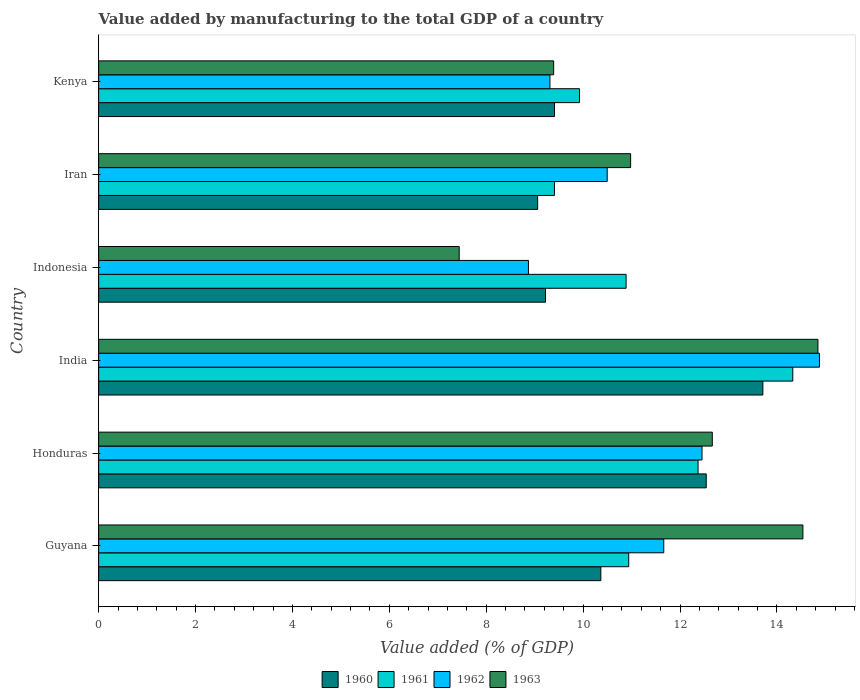How many different coloured bars are there?
Your answer should be very brief. 4. How many groups of bars are there?
Provide a short and direct response. 6. Are the number of bars on each tick of the Y-axis equal?
Your response must be concise. Yes. How many bars are there on the 1st tick from the bottom?
Keep it short and to the point. 4. What is the label of the 6th group of bars from the top?
Your answer should be very brief. Guyana. In how many cases, is the number of bars for a given country not equal to the number of legend labels?
Offer a terse response. 0. What is the value added by manufacturing to the total GDP in 1961 in Honduras?
Your response must be concise. 12.37. Across all countries, what is the maximum value added by manufacturing to the total GDP in 1961?
Your answer should be very brief. 14.33. Across all countries, what is the minimum value added by manufacturing to the total GDP in 1961?
Provide a short and direct response. 9.41. In which country was the value added by manufacturing to the total GDP in 1963 maximum?
Keep it short and to the point. India. What is the total value added by manufacturing to the total GDP in 1960 in the graph?
Make the answer very short. 64.31. What is the difference between the value added by manufacturing to the total GDP in 1960 in India and that in Kenya?
Provide a succinct answer. 4.3. What is the difference between the value added by manufacturing to the total GDP in 1961 in Guyana and the value added by manufacturing to the total GDP in 1960 in Indonesia?
Ensure brevity in your answer.  1.72. What is the average value added by manufacturing to the total GDP in 1963 per country?
Your answer should be very brief. 11.64. What is the difference between the value added by manufacturing to the total GDP in 1962 and value added by manufacturing to the total GDP in 1963 in Kenya?
Your answer should be compact. -0.08. In how many countries, is the value added by manufacturing to the total GDP in 1963 greater than 11.2 %?
Provide a short and direct response. 3. What is the ratio of the value added by manufacturing to the total GDP in 1961 in Guyana to that in Honduras?
Your answer should be compact. 0.88. Is the value added by manufacturing to the total GDP in 1960 in India less than that in Indonesia?
Your answer should be compact. No. Is the difference between the value added by manufacturing to the total GDP in 1962 in Guyana and Indonesia greater than the difference between the value added by manufacturing to the total GDP in 1963 in Guyana and Indonesia?
Offer a terse response. No. What is the difference between the highest and the second highest value added by manufacturing to the total GDP in 1963?
Make the answer very short. 0.31. What is the difference between the highest and the lowest value added by manufacturing to the total GDP in 1962?
Your answer should be compact. 6.01. In how many countries, is the value added by manufacturing to the total GDP in 1961 greater than the average value added by manufacturing to the total GDP in 1961 taken over all countries?
Ensure brevity in your answer.  2. Is the sum of the value added by manufacturing to the total GDP in 1960 in Iran and Kenya greater than the maximum value added by manufacturing to the total GDP in 1963 across all countries?
Offer a very short reply. Yes. What does the 4th bar from the bottom in India represents?
Make the answer very short. 1963. Are all the bars in the graph horizontal?
Ensure brevity in your answer.  Yes. How many countries are there in the graph?
Keep it short and to the point. 6. Does the graph contain any zero values?
Offer a terse response. No. Does the graph contain grids?
Keep it short and to the point. No. Where does the legend appear in the graph?
Ensure brevity in your answer.  Bottom center. What is the title of the graph?
Your response must be concise. Value added by manufacturing to the total GDP of a country. Does "1997" appear as one of the legend labels in the graph?
Offer a terse response. No. What is the label or title of the X-axis?
Provide a short and direct response. Value added (% of GDP). What is the label or title of the Y-axis?
Provide a short and direct response. Country. What is the Value added (% of GDP) in 1960 in Guyana?
Make the answer very short. 10.37. What is the Value added (% of GDP) in 1961 in Guyana?
Offer a very short reply. 10.94. What is the Value added (% of GDP) of 1962 in Guyana?
Offer a very short reply. 11.66. What is the Value added (% of GDP) of 1963 in Guyana?
Offer a terse response. 14.54. What is the Value added (% of GDP) in 1960 in Honduras?
Ensure brevity in your answer.  12.54. What is the Value added (% of GDP) in 1961 in Honduras?
Provide a short and direct response. 12.37. What is the Value added (% of GDP) in 1962 in Honduras?
Offer a terse response. 12.45. What is the Value added (% of GDP) of 1963 in Honduras?
Your response must be concise. 12.67. What is the Value added (% of GDP) in 1960 in India?
Keep it short and to the point. 13.71. What is the Value added (% of GDP) in 1961 in India?
Your answer should be very brief. 14.33. What is the Value added (% of GDP) in 1962 in India?
Offer a terse response. 14.88. What is the Value added (% of GDP) of 1963 in India?
Provide a succinct answer. 14.85. What is the Value added (% of GDP) of 1960 in Indonesia?
Make the answer very short. 9.22. What is the Value added (% of GDP) in 1961 in Indonesia?
Provide a short and direct response. 10.89. What is the Value added (% of GDP) in 1962 in Indonesia?
Make the answer very short. 8.87. What is the Value added (% of GDP) in 1963 in Indonesia?
Keep it short and to the point. 7.44. What is the Value added (% of GDP) in 1960 in Iran?
Give a very brief answer. 9.06. What is the Value added (% of GDP) of 1961 in Iran?
Offer a very short reply. 9.41. What is the Value added (% of GDP) of 1962 in Iran?
Keep it short and to the point. 10.5. What is the Value added (% of GDP) of 1963 in Iran?
Your answer should be compact. 10.98. What is the Value added (% of GDP) in 1960 in Kenya?
Give a very brief answer. 9.41. What is the Value added (% of GDP) in 1961 in Kenya?
Make the answer very short. 9.93. What is the Value added (% of GDP) in 1962 in Kenya?
Your answer should be very brief. 9.32. What is the Value added (% of GDP) in 1963 in Kenya?
Give a very brief answer. 9.39. Across all countries, what is the maximum Value added (% of GDP) in 1960?
Your response must be concise. 13.71. Across all countries, what is the maximum Value added (% of GDP) in 1961?
Offer a terse response. 14.33. Across all countries, what is the maximum Value added (% of GDP) of 1962?
Your answer should be very brief. 14.88. Across all countries, what is the maximum Value added (% of GDP) of 1963?
Your answer should be very brief. 14.85. Across all countries, what is the minimum Value added (% of GDP) in 1960?
Make the answer very short. 9.06. Across all countries, what is the minimum Value added (% of GDP) in 1961?
Give a very brief answer. 9.41. Across all countries, what is the minimum Value added (% of GDP) in 1962?
Your answer should be compact. 8.87. Across all countries, what is the minimum Value added (% of GDP) of 1963?
Your answer should be very brief. 7.44. What is the total Value added (% of GDP) of 1960 in the graph?
Provide a succinct answer. 64.31. What is the total Value added (% of GDP) in 1961 in the graph?
Your response must be concise. 67.86. What is the total Value added (% of GDP) in 1962 in the graph?
Your answer should be compact. 67.68. What is the total Value added (% of GDP) in 1963 in the graph?
Ensure brevity in your answer.  69.86. What is the difference between the Value added (% of GDP) of 1960 in Guyana and that in Honduras?
Ensure brevity in your answer.  -2.18. What is the difference between the Value added (% of GDP) in 1961 in Guyana and that in Honduras?
Offer a terse response. -1.43. What is the difference between the Value added (% of GDP) of 1962 in Guyana and that in Honduras?
Offer a terse response. -0.79. What is the difference between the Value added (% of GDP) in 1963 in Guyana and that in Honduras?
Provide a short and direct response. 1.87. What is the difference between the Value added (% of GDP) in 1960 in Guyana and that in India?
Your answer should be compact. -3.34. What is the difference between the Value added (% of GDP) of 1961 in Guyana and that in India?
Your answer should be compact. -3.39. What is the difference between the Value added (% of GDP) of 1962 in Guyana and that in India?
Provide a succinct answer. -3.21. What is the difference between the Value added (% of GDP) of 1963 in Guyana and that in India?
Offer a very short reply. -0.31. What is the difference between the Value added (% of GDP) of 1960 in Guyana and that in Indonesia?
Offer a terse response. 1.14. What is the difference between the Value added (% of GDP) in 1961 in Guyana and that in Indonesia?
Offer a very short reply. 0.05. What is the difference between the Value added (% of GDP) of 1962 in Guyana and that in Indonesia?
Your answer should be very brief. 2.79. What is the difference between the Value added (% of GDP) in 1963 in Guyana and that in Indonesia?
Your response must be concise. 7.09. What is the difference between the Value added (% of GDP) in 1960 in Guyana and that in Iran?
Offer a very short reply. 1.3. What is the difference between the Value added (% of GDP) in 1961 in Guyana and that in Iran?
Ensure brevity in your answer.  1.53. What is the difference between the Value added (% of GDP) in 1962 in Guyana and that in Iran?
Your response must be concise. 1.17. What is the difference between the Value added (% of GDP) of 1963 in Guyana and that in Iran?
Your answer should be very brief. 3.56. What is the difference between the Value added (% of GDP) of 1960 in Guyana and that in Kenya?
Your answer should be very brief. 0.96. What is the difference between the Value added (% of GDP) in 1961 in Guyana and that in Kenya?
Make the answer very short. 1.02. What is the difference between the Value added (% of GDP) in 1962 in Guyana and that in Kenya?
Make the answer very short. 2.35. What is the difference between the Value added (% of GDP) of 1963 in Guyana and that in Kenya?
Keep it short and to the point. 5.14. What is the difference between the Value added (% of GDP) in 1960 in Honduras and that in India?
Offer a terse response. -1.17. What is the difference between the Value added (% of GDP) of 1961 in Honduras and that in India?
Make the answer very short. -1.96. What is the difference between the Value added (% of GDP) of 1962 in Honduras and that in India?
Give a very brief answer. -2.42. What is the difference between the Value added (% of GDP) of 1963 in Honduras and that in India?
Your response must be concise. -2.18. What is the difference between the Value added (% of GDP) of 1960 in Honduras and that in Indonesia?
Ensure brevity in your answer.  3.32. What is the difference between the Value added (% of GDP) in 1961 in Honduras and that in Indonesia?
Provide a short and direct response. 1.49. What is the difference between the Value added (% of GDP) of 1962 in Honduras and that in Indonesia?
Your answer should be compact. 3.58. What is the difference between the Value added (% of GDP) of 1963 in Honduras and that in Indonesia?
Provide a short and direct response. 5.22. What is the difference between the Value added (% of GDP) in 1960 in Honduras and that in Iran?
Offer a very short reply. 3.48. What is the difference between the Value added (% of GDP) of 1961 in Honduras and that in Iran?
Provide a succinct answer. 2.96. What is the difference between the Value added (% of GDP) of 1962 in Honduras and that in Iran?
Your answer should be compact. 1.96. What is the difference between the Value added (% of GDP) in 1963 in Honduras and that in Iran?
Provide a short and direct response. 1.69. What is the difference between the Value added (% of GDP) of 1960 in Honduras and that in Kenya?
Your response must be concise. 3.13. What is the difference between the Value added (% of GDP) of 1961 in Honduras and that in Kenya?
Provide a short and direct response. 2.45. What is the difference between the Value added (% of GDP) of 1962 in Honduras and that in Kenya?
Make the answer very short. 3.14. What is the difference between the Value added (% of GDP) of 1963 in Honduras and that in Kenya?
Your response must be concise. 3.27. What is the difference between the Value added (% of GDP) of 1960 in India and that in Indonesia?
Make the answer very short. 4.49. What is the difference between the Value added (% of GDP) in 1961 in India and that in Indonesia?
Offer a terse response. 3.44. What is the difference between the Value added (% of GDP) of 1962 in India and that in Indonesia?
Your answer should be very brief. 6.01. What is the difference between the Value added (% of GDP) in 1963 in India and that in Indonesia?
Keep it short and to the point. 7.4. What is the difference between the Value added (% of GDP) in 1960 in India and that in Iran?
Give a very brief answer. 4.65. What is the difference between the Value added (% of GDP) of 1961 in India and that in Iran?
Keep it short and to the point. 4.92. What is the difference between the Value added (% of GDP) in 1962 in India and that in Iran?
Your response must be concise. 4.38. What is the difference between the Value added (% of GDP) in 1963 in India and that in Iran?
Offer a terse response. 3.87. What is the difference between the Value added (% of GDP) of 1960 in India and that in Kenya?
Offer a very short reply. 4.3. What is the difference between the Value added (% of GDP) in 1961 in India and that in Kenya?
Your answer should be compact. 4.4. What is the difference between the Value added (% of GDP) in 1962 in India and that in Kenya?
Make the answer very short. 5.56. What is the difference between the Value added (% of GDP) of 1963 in India and that in Kenya?
Offer a very short reply. 5.45. What is the difference between the Value added (% of GDP) in 1960 in Indonesia and that in Iran?
Your answer should be very brief. 0.16. What is the difference between the Value added (% of GDP) of 1961 in Indonesia and that in Iran?
Ensure brevity in your answer.  1.48. What is the difference between the Value added (% of GDP) of 1962 in Indonesia and that in Iran?
Ensure brevity in your answer.  -1.63. What is the difference between the Value added (% of GDP) in 1963 in Indonesia and that in Iran?
Ensure brevity in your answer.  -3.54. What is the difference between the Value added (% of GDP) of 1960 in Indonesia and that in Kenya?
Offer a terse response. -0.19. What is the difference between the Value added (% of GDP) in 1961 in Indonesia and that in Kenya?
Your response must be concise. 0.96. What is the difference between the Value added (% of GDP) in 1962 in Indonesia and that in Kenya?
Give a very brief answer. -0.44. What is the difference between the Value added (% of GDP) of 1963 in Indonesia and that in Kenya?
Your answer should be very brief. -1.95. What is the difference between the Value added (% of GDP) of 1960 in Iran and that in Kenya?
Offer a very short reply. -0.35. What is the difference between the Value added (% of GDP) in 1961 in Iran and that in Kenya?
Offer a terse response. -0.52. What is the difference between the Value added (% of GDP) of 1962 in Iran and that in Kenya?
Your response must be concise. 1.18. What is the difference between the Value added (% of GDP) in 1963 in Iran and that in Kenya?
Give a very brief answer. 1.59. What is the difference between the Value added (% of GDP) of 1960 in Guyana and the Value added (% of GDP) of 1961 in Honduras?
Your answer should be very brief. -2.01. What is the difference between the Value added (% of GDP) in 1960 in Guyana and the Value added (% of GDP) in 1962 in Honduras?
Your answer should be compact. -2.09. What is the difference between the Value added (% of GDP) in 1960 in Guyana and the Value added (% of GDP) in 1963 in Honduras?
Make the answer very short. -2.3. What is the difference between the Value added (% of GDP) of 1961 in Guyana and the Value added (% of GDP) of 1962 in Honduras?
Make the answer very short. -1.51. What is the difference between the Value added (% of GDP) of 1961 in Guyana and the Value added (% of GDP) of 1963 in Honduras?
Give a very brief answer. -1.73. What is the difference between the Value added (% of GDP) of 1962 in Guyana and the Value added (% of GDP) of 1963 in Honduras?
Your answer should be compact. -1. What is the difference between the Value added (% of GDP) of 1960 in Guyana and the Value added (% of GDP) of 1961 in India?
Make the answer very short. -3.96. What is the difference between the Value added (% of GDP) in 1960 in Guyana and the Value added (% of GDP) in 1962 in India?
Your response must be concise. -4.51. What is the difference between the Value added (% of GDP) in 1960 in Guyana and the Value added (% of GDP) in 1963 in India?
Provide a succinct answer. -4.48. What is the difference between the Value added (% of GDP) in 1961 in Guyana and the Value added (% of GDP) in 1962 in India?
Your answer should be compact. -3.94. What is the difference between the Value added (% of GDP) in 1961 in Guyana and the Value added (% of GDP) in 1963 in India?
Your answer should be very brief. -3.91. What is the difference between the Value added (% of GDP) in 1962 in Guyana and the Value added (% of GDP) in 1963 in India?
Provide a succinct answer. -3.18. What is the difference between the Value added (% of GDP) of 1960 in Guyana and the Value added (% of GDP) of 1961 in Indonesia?
Give a very brief answer. -0.52. What is the difference between the Value added (% of GDP) of 1960 in Guyana and the Value added (% of GDP) of 1962 in Indonesia?
Provide a succinct answer. 1.49. What is the difference between the Value added (% of GDP) of 1960 in Guyana and the Value added (% of GDP) of 1963 in Indonesia?
Offer a terse response. 2.92. What is the difference between the Value added (% of GDP) in 1961 in Guyana and the Value added (% of GDP) in 1962 in Indonesia?
Your answer should be compact. 2.07. What is the difference between the Value added (% of GDP) in 1961 in Guyana and the Value added (% of GDP) in 1963 in Indonesia?
Provide a succinct answer. 3.5. What is the difference between the Value added (% of GDP) of 1962 in Guyana and the Value added (% of GDP) of 1963 in Indonesia?
Make the answer very short. 4.22. What is the difference between the Value added (% of GDP) in 1960 in Guyana and the Value added (% of GDP) in 1961 in Iran?
Your response must be concise. 0.96. What is the difference between the Value added (% of GDP) in 1960 in Guyana and the Value added (% of GDP) in 1962 in Iran?
Your answer should be very brief. -0.13. What is the difference between the Value added (% of GDP) of 1960 in Guyana and the Value added (% of GDP) of 1963 in Iran?
Offer a very short reply. -0.61. What is the difference between the Value added (% of GDP) of 1961 in Guyana and the Value added (% of GDP) of 1962 in Iran?
Your answer should be very brief. 0.44. What is the difference between the Value added (% of GDP) of 1961 in Guyana and the Value added (% of GDP) of 1963 in Iran?
Offer a very short reply. -0.04. What is the difference between the Value added (% of GDP) in 1962 in Guyana and the Value added (% of GDP) in 1963 in Iran?
Your response must be concise. 0.68. What is the difference between the Value added (% of GDP) of 1960 in Guyana and the Value added (% of GDP) of 1961 in Kenya?
Your response must be concise. 0.44. What is the difference between the Value added (% of GDP) of 1960 in Guyana and the Value added (% of GDP) of 1962 in Kenya?
Give a very brief answer. 1.05. What is the difference between the Value added (% of GDP) in 1960 in Guyana and the Value added (% of GDP) in 1963 in Kenya?
Your answer should be compact. 0.97. What is the difference between the Value added (% of GDP) of 1961 in Guyana and the Value added (% of GDP) of 1962 in Kenya?
Provide a succinct answer. 1.63. What is the difference between the Value added (% of GDP) of 1961 in Guyana and the Value added (% of GDP) of 1963 in Kenya?
Provide a short and direct response. 1.55. What is the difference between the Value added (% of GDP) of 1962 in Guyana and the Value added (% of GDP) of 1963 in Kenya?
Make the answer very short. 2.27. What is the difference between the Value added (% of GDP) of 1960 in Honduras and the Value added (% of GDP) of 1961 in India?
Offer a terse response. -1.79. What is the difference between the Value added (% of GDP) in 1960 in Honduras and the Value added (% of GDP) in 1962 in India?
Your answer should be very brief. -2.34. What is the difference between the Value added (% of GDP) of 1960 in Honduras and the Value added (% of GDP) of 1963 in India?
Keep it short and to the point. -2.31. What is the difference between the Value added (% of GDP) in 1961 in Honduras and the Value added (% of GDP) in 1962 in India?
Make the answer very short. -2.51. What is the difference between the Value added (% of GDP) of 1961 in Honduras and the Value added (% of GDP) of 1963 in India?
Offer a terse response. -2.47. What is the difference between the Value added (% of GDP) of 1962 in Honduras and the Value added (% of GDP) of 1963 in India?
Give a very brief answer. -2.39. What is the difference between the Value added (% of GDP) of 1960 in Honduras and the Value added (% of GDP) of 1961 in Indonesia?
Offer a terse response. 1.65. What is the difference between the Value added (% of GDP) in 1960 in Honduras and the Value added (% of GDP) in 1962 in Indonesia?
Give a very brief answer. 3.67. What is the difference between the Value added (% of GDP) of 1960 in Honduras and the Value added (% of GDP) of 1963 in Indonesia?
Provide a short and direct response. 5.1. What is the difference between the Value added (% of GDP) in 1961 in Honduras and the Value added (% of GDP) in 1962 in Indonesia?
Give a very brief answer. 3.5. What is the difference between the Value added (% of GDP) in 1961 in Honduras and the Value added (% of GDP) in 1963 in Indonesia?
Give a very brief answer. 4.93. What is the difference between the Value added (% of GDP) in 1962 in Honduras and the Value added (% of GDP) in 1963 in Indonesia?
Your answer should be compact. 5.01. What is the difference between the Value added (% of GDP) of 1960 in Honduras and the Value added (% of GDP) of 1961 in Iran?
Provide a short and direct response. 3.13. What is the difference between the Value added (% of GDP) of 1960 in Honduras and the Value added (% of GDP) of 1962 in Iran?
Give a very brief answer. 2.04. What is the difference between the Value added (% of GDP) in 1960 in Honduras and the Value added (% of GDP) in 1963 in Iran?
Your answer should be very brief. 1.56. What is the difference between the Value added (% of GDP) in 1961 in Honduras and the Value added (% of GDP) in 1962 in Iran?
Provide a succinct answer. 1.88. What is the difference between the Value added (% of GDP) of 1961 in Honduras and the Value added (% of GDP) of 1963 in Iran?
Make the answer very short. 1.39. What is the difference between the Value added (% of GDP) of 1962 in Honduras and the Value added (% of GDP) of 1963 in Iran?
Keep it short and to the point. 1.47. What is the difference between the Value added (% of GDP) in 1960 in Honduras and the Value added (% of GDP) in 1961 in Kenya?
Your response must be concise. 2.62. What is the difference between the Value added (% of GDP) of 1960 in Honduras and the Value added (% of GDP) of 1962 in Kenya?
Your answer should be compact. 3.23. What is the difference between the Value added (% of GDP) in 1960 in Honduras and the Value added (% of GDP) in 1963 in Kenya?
Keep it short and to the point. 3.15. What is the difference between the Value added (% of GDP) of 1961 in Honduras and the Value added (% of GDP) of 1962 in Kenya?
Your answer should be compact. 3.06. What is the difference between the Value added (% of GDP) in 1961 in Honduras and the Value added (% of GDP) in 1963 in Kenya?
Your answer should be compact. 2.98. What is the difference between the Value added (% of GDP) of 1962 in Honduras and the Value added (% of GDP) of 1963 in Kenya?
Your answer should be very brief. 3.06. What is the difference between the Value added (% of GDP) in 1960 in India and the Value added (% of GDP) in 1961 in Indonesia?
Offer a terse response. 2.82. What is the difference between the Value added (% of GDP) in 1960 in India and the Value added (% of GDP) in 1962 in Indonesia?
Keep it short and to the point. 4.84. What is the difference between the Value added (% of GDP) in 1960 in India and the Value added (% of GDP) in 1963 in Indonesia?
Make the answer very short. 6.27. What is the difference between the Value added (% of GDP) in 1961 in India and the Value added (% of GDP) in 1962 in Indonesia?
Ensure brevity in your answer.  5.46. What is the difference between the Value added (% of GDP) in 1961 in India and the Value added (% of GDP) in 1963 in Indonesia?
Provide a short and direct response. 6.89. What is the difference between the Value added (% of GDP) in 1962 in India and the Value added (% of GDP) in 1963 in Indonesia?
Make the answer very short. 7.44. What is the difference between the Value added (% of GDP) in 1960 in India and the Value added (% of GDP) in 1961 in Iran?
Provide a succinct answer. 4.3. What is the difference between the Value added (% of GDP) of 1960 in India and the Value added (% of GDP) of 1962 in Iran?
Offer a very short reply. 3.21. What is the difference between the Value added (% of GDP) in 1960 in India and the Value added (% of GDP) in 1963 in Iran?
Your answer should be very brief. 2.73. What is the difference between the Value added (% of GDP) in 1961 in India and the Value added (% of GDP) in 1962 in Iran?
Keep it short and to the point. 3.83. What is the difference between the Value added (% of GDP) of 1961 in India and the Value added (% of GDP) of 1963 in Iran?
Offer a very short reply. 3.35. What is the difference between the Value added (% of GDP) of 1962 in India and the Value added (% of GDP) of 1963 in Iran?
Your answer should be very brief. 3.9. What is the difference between the Value added (% of GDP) of 1960 in India and the Value added (% of GDP) of 1961 in Kenya?
Make the answer very short. 3.78. What is the difference between the Value added (% of GDP) in 1960 in India and the Value added (% of GDP) in 1962 in Kenya?
Your response must be concise. 4.39. What is the difference between the Value added (% of GDP) of 1960 in India and the Value added (% of GDP) of 1963 in Kenya?
Your response must be concise. 4.32. What is the difference between the Value added (% of GDP) in 1961 in India and the Value added (% of GDP) in 1962 in Kenya?
Give a very brief answer. 5.01. What is the difference between the Value added (% of GDP) in 1961 in India and the Value added (% of GDP) in 1963 in Kenya?
Provide a short and direct response. 4.94. What is the difference between the Value added (% of GDP) of 1962 in India and the Value added (% of GDP) of 1963 in Kenya?
Your answer should be very brief. 5.49. What is the difference between the Value added (% of GDP) in 1960 in Indonesia and the Value added (% of GDP) in 1961 in Iran?
Make the answer very short. -0.18. What is the difference between the Value added (% of GDP) in 1960 in Indonesia and the Value added (% of GDP) in 1962 in Iran?
Provide a succinct answer. -1.27. What is the difference between the Value added (% of GDP) of 1960 in Indonesia and the Value added (% of GDP) of 1963 in Iran?
Offer a very short reply. -1.76. What is the difference between the Value added (% of GDP) of 1961 in Indonesia and the Value added (% of GDP) of 1962 in Iran?
Provide a succinct answer. 0.39. What is the difference between the Value added (% of GDP) of 1961 in Indonesia and the Value added (% of GDP) of 1963 in Iran?
Your response must be concise. -0.09. What is the difference between the Value added (% of GDP) of 1962 in Indonesia and the Value added (% of GDP) of 1963 in Iran?
Your answer should be very brief. -2.11. What is the difference between the Value added (% of GDP) in 1960 in Indonesia and the Value added (% of GDP) in 1961 in Kenya?
Provide a succinct answer. -0.7. What is the difference between the Value added (% of GDP) in 1960 in Indonesia and the Value added (% of GDP) in 1962 in Kenya?
Make the answer very short. -0.09. What is the difference between the Value added (% of GDP) in 1960 in Indonesia and the Value added (% of GDP) in 1963 in Kenya?
Give a very brief answer. -0.17. What is the difference between the Value added (% of GDP) of 1961 in Indonesia and the Value added (% of GDP) of 1962 in Kenya?
Give a very brief answer. 1.57. What is the difference between the Value added (% of GDP) in 1961 in Indonesia and the Value added (% of GDP) in 1963 in Kenya?
Offer a terse response. 1.5. What is the difference between the Value added (% of GDP) of 1962 in Indonesia and the Value added (% of GDP) of 1963 in Kenya?
Your response must be concise. -0.52. What is the difference between the Value added (% of GDP) in 1960 in Iran and the Value added (% of GDP) in 1961 in Kenya?
Offer a very short reply. -0.86. What is the difference between the Value added (% of GDP) of 1960 in Iran and the Value added (% of GDP) of 1962 in Kenya?
Keep it short and to the point. -0.25. What is the difference between the Value added (% of GDP) in 1960 in Iran and the Value added (% of GDP) in 1963 in Kenya?
Offer a terse response. -0.33. What is the difference between the Value added (% of GDP) in 1961 in Iran and the Value added (% of GDP) in 1962 in Kenya?
Provide a succinct answer. 0.09. What is the difference between the Value added (% of GDP) in 1961 in Iran and the Value added (% of GDP) in 1963 in Kenya?
Provide a short and direct response. 0.02. What is the difference between the Value added (% of GDP) of 1962 in Iran and the Value added (% of GDP) of 1963 in Kenya?
Offer a very short reply. 1.11. What is the average Value added (% of GDP) in 1960 per country?
Your answer should be compact. 10.72. What is the average Value added (% of GDP) in 1961 per country?
Offer a terse response. 11.31. What is the average Value added (% of GDP) in 1962 per country?
Give a very brief answer. 11.28. What is the average Value added (% of GDP) in 1963 per country?
Give a very brief answer. 11.64. What is the difference between the Value added (% of GDP) in 1960 and Value added (% of GDP) in 1961 in Guyana?
Ensure brevity in your answer.  -0.58. What is the difference between the Value added (% of GDP) in 1960 and Value added (% of GDP) in 1962 in Guyana?
Make the answer very short. -1.3. What is the difference between the Value added (% of GDP) in 1960 and Value added (% of GDP) in 1963 in Guyana?
Give a very brief answer. -4.17. What is the difference between the Value added (% of GDP) in 1961 and Value added (% of GDP) in 1962 in Guyana?
Your answer should be compact. -0.72. What is the difference between the Value added (% of GDP) in 1961 and Value added (% of GDP) in 1963 in Guyana?
Offer a very short reply. -3.6. What is the difference between the Value added (% of GDP) of 1962 and Value added (% of GDP) of 1963 in Guyana?
Keep it short and to the point. -2.87. What is the difference between the Value added (% of GDP) of 1960 and Value added (% of GDP) of 1961 in Honduras?
Provide a succinct answer. 0.17. What is the difference between the Value added (% of GDP) of 1960 and Value added (% of GDP) of 1962 in Honduras?
Offer a very short reply. 0.09. What is the difference between the Value added (% of GDP) in 1960 and Value added (% of GDP) in 1963 in Honduras?
Your answer should be very brief. -0.13. What is the difference between the Value added (% of GDP) of 1961 and Value added (% of GDP) of 1962 in Honduras?
Offer a very short reply. -0.08. What is the difference between the Value added (% of GDP) in 1961 and Value added (% of GDP) in 1963 in Honduras?
Ensure brevity in your answer.  -0.29. What is the difference between the Value added (% of GDP) of 1962 and Value added (% of GDP) of 1963 in Honduras?
Offer a very short reply. -0.21. What is the difference between the Value added (% of GDP) of 1960 and Value added (% of GDP) of 1961 in India?
Your answer should be compact. -0.62. What is the difference between the Value added (% of GDP) in 1960 and Value added (% of GDP) in 1962 in India?
Your response must be concise. -1.17. What is the difference between the Value added (% of GDP) in 1960 and Value added (% of GDP) in 1963 in India?
Provide a succinct answer. -1.14. What is the difference between the Value added (% of GDP) in 1961 and Value added (% of GDP) in 1962 in India?
Ensure brevity in your answer.  -0.55. What is the difference between the Value added (% of GDP) in 1961 and Value added (% of GDP) in 1963 in India?
Your answer should be very brief. -0.52. What is the difference between the Value added (% of GDP) in 1962 and Value added (% of GDP) in 1963 in India?
Your answer should be very brief. 0.03. What is the difference between the Value added (% of GDP) of 1960 and Value added (% of GDP) of 1961 in Indonesia?
Ensure brevity in your answer.  -1.66. What is the difference between the Value added (% of GDP) in 1960 and Value added (% of GDP) in 1962 in Indonesia?
Provide a short and direct response. 0.35. What is the difference between the Value added (% of GDP) of 1960 and Value added (% of GDP) of 1963 in Indonesia?
Keep it short and to the point. 1.78. What is the difference between the Value added (% of GDP) in 1961 and Value added (% of GDP) in 1962 in Indonesia?
Your response must be concise. 2.02. What is the difference between the Value added (% of GDP) in 1961 and Value added (% of GDP) in 1963 in Indonesia?
Provide a short and direct response. 3.44. What is the difference between the Value added (% of GDP) in 1962 and Value added (% of GDP) in 1963 in Indonesia?
Your response must be concise. 1.43. What is the difference between the Value added (% of GDP) in 1960 and Value added (% of GDP) in 1961 in Iran?
Your answer should be compact. -0.35. What is the difference between the Value added (% of GDP) of 1960 and Value added (% of GDP) of 1962 in Iran?
Your response must be concise. -1.44. What is the difference between the Value added (% of GDP) of 1960 and Value added (% of GDP) of 1963 in Iran?
Make the answer very short. -1.92. What is the difference between the Value added (% of GDP) of 1961 and Value added (% of GDP) of 1962 in Iran?
Provide a succinct answer. -1.09. What is the difference between the Value added (% of GDP) in 1961 and Value added (% of GDP) in 1963 in Iran?
Your answer should be very brief. -1.57. What is the difference between the Value added (% of GDP) in 1962 and Value added (% of GDP) in 1963 in Iran?
Offer a terse response. -0.48. What is the difference between the Value added (% of GDP) in 1960 and Value added (% of GDP) in 1961 in Kenya?
Keep it short and to the point. -0.52. What is the difference between the Value added (% of GDP) in 1960 and Value added (% of GDP) in 1962 in Kenya?
Make the answer very short. 0.09. What is the difference between the Value added (% of GDP) in 1960 and Value added (% of GDP) in 1963 in Kenya?
Your answer should be very brief. 0.02. What is the difference between the Value added (% of GDP) in 1961 and Value added (% of GDP) in 1962 in Kenya?
Provide a succinct answer. 0.61. What is the difference between the Value added (% of GDP) of 1961 and Value added (% of GDP) of 1963 in Kenya?
Provide a short and direct response. 0.53. What is the difference between the Value added (% of GDP) of 1962 and Value added (% of GDP) of 1963 in Kenya?
Keep it short and to the point. -0.08. What is the ratio of the Value added (% of GDP) of 1960 in Guyana to that in Honduras?
Offer a very short reply. 0.83. What is the ratio of the Value added (% of GDP) in 1961 in Guyana to that in Honduras?
Make the answer very short. 0.88. What is the ratio of the Value added (% of GDP) of 1962 in Guyana to that in Honduras?
Keep it short and to the point. 0.94. What is the ratio of the Value added (% of GDP) in 1963 in Guyana to that in Honduras?
Provide a succinct answer. 1.15. What is the ratio of the Value added (% of GDP) in 1960 in Guyana to that in India?
Provide a short and direct response. 0.76. What is the ratio of the Value added (% of GDP) of 1961 in Guyana to that in India?
Offer a terse response. 0.76. What is the ratio of the Value added (% of GDP) of 1962 in Guyana to that in India?
Your answer should be very brief. 0.78. What is the ratio of the Value added (% of GDP) in 1963 in Guyana to that in India?
Your response must be concise. 0.98. What is the ratio of the Value added (% of GDP) in 1960 in Guyana to that in Indonesia?
Make the answer very short. 1.12. What is the ratio of the Value added (% of GDP) in 1962 in Guyana to that in Indonesia?
Your response must be concise. 1.31. What is the ratio of the Value added (% of GDP) of 1963 in Guyana to that in Indonesia?
Provide a short and direct response. 1.95. What is the ratio of the Value added (% of GDP) in 1960 in Guyana to that in Iran?
Provide a short and direct response. 1.14. What is the ratio of the Value added (% of GDP) in 1961 in Guyana to that in Iran?
Your answer should be compact. 1.16. What is the ratio of the Value added (% of GDP) in 1962 in Guyana to that in Iran?
Keep it short and to the point. 1.11. What is the ratio of the Value added (% of GDP) of 1963 in Guyana to that in Iran?
Offer a terse response. 1.32. What is the ratio of the Value added (% of GDP) in 1960 in Guyana to that in Kenya?
Give a very brief answer. 1.1. What is the ratio of the Value added (% of GDP) in 1961 in Guyana to that in Kenya?
Provide a succinct answer. 1.1. What is the ratio of the Value added (% of GDP) of 1962 in Guyana to that in Kenya?
Your answer should be compact. 1.25. What is the ratio of the Value added (% of GDP) in 1963 in Guyana to that in Kenya?
Ensure brevity in your answer.  1.55. What is the ratio of the Value added (% of GDP) in 1960 in Honduras to that in India?
Ensure brevity in your answer.  0.91. What is the ratio of the Value added (% of GDP) in 1961 in Honduras to that in India?
Keep it short and to the point. 0.86. What is the ratio of the Value added (% of GDP) of 1962 in Honduras to that in India?
Keep it short and to the point. 0.84. What is the ratio of the Value added (% of GDP) in 1963 in Honduras to that in India?
Your response must be concise. 0.85. What is the ratio of the Value added (% of GDP) of 1960 in Honduras to that in Indonesia?
Offer a very short reply. 1.36. What is the ratio of the Value added (% of GDP) in 1961 in Honduras to that in Indonesia?
Your answer should be very brief. 1.14. What is the ratio of the Value added (% of GDP) in 1962 in Honduras to that in Indonesia?
Your answer should be compact. 1.4. What is the ratio of the Value added (% of GDP) in 1963 in Honduras to that in Indonesia?
Your answer should be very brief. 1.7. What is the ratio of the Value added (% of GDP) of 1960 in Honduras to that in Iran?
Make the answer very short. 1.38. What is the ratio of the Value added (% of GDP) of 1961 in Honduras to that in Iran?
Make the answer very short. 1.32. What is the ratio of the Value added (% of GDP) in 1962 in Honduras to that in Iran?
Provide a succinct answer. 1.19. What is the ratio of the Value added (% of GDP) in 1963 in Honduras to that in Iran?
Your response must be concise. 1.15. What is the ratio of the Value added (% of GDP) of 1960 in Honduras to that in Kenya?
Offer a terse response. 1.33. What is the ratio of the Value added (% of GDP) in 1961 in Honduras to that in Kenya?
Keep it short and to the point. 1.25. What is the ratio of the Value added (% of GDP) of 1962 in Honduras to that in Kenya?
Your response must be concise. 1.34. What is the ratio of the Value added (% of GDP) of 1963 in Honduras to that in Kenya?
Make the answer very short. 1.35. What is the ratio of the Value added (% of GDP) in 1960 in India to that in Indonesia?
Give a very brief answer. 1.49. What is the ratio of the Value added (% of GDP) in 1961 in India to that in Indonesia?
Your response must be concise. 1.32. What is the ratio of the Value added (% of GDP) of 1962 in India to that in Indonesia?
Make the answer very short. 1.68. What is the ratio of the Value added (% of GDP) in 1963 in India to that in Indonesia?
Your response must be concise. 1.99. What is the ratio of the Value added (% of GDP) in 1960 in India to that in Iran?
Offer a terse response. 1.51. What is the ratio of the Value added (% of GDP) of 1961 in India to that in Iran?
Your answer should be compact. 1.52. What is the ratio of the Value added (% of GDP) in 1962 in India to that in Iran?
Provide a short and direct response. 1.42. What is the ratio of the Value added (% of GDP) in 1963 in India to that in Iran?
Ensure brevity in your answer.  1.35. What is the ratio of the Value added (% of GDP) in 1960 in India to that in Kenya?
Your answer should be very brief. 1.46. What is the ratio of the Value added (% of GDP) in 1961 in India to that in Kenya?
Offer a terse response. 1.44. What is the ratio of the Value added (% of GDP) of 1962 in India to that in Kenya?
Your answer should be compact. 1.6. What is the ratio of the Value added (% of GDP) in 1963 in India to that in Kenya?
Offer a very short reply. 1.58. What is the ratio of the Value added (% of GDP) of 1960 in Indonesia to that in Iran?
Offer a very short reply. 1.02. What is the ratio of the Value added (% of GDP) of 1961 in Indonesia to that in Iran?
Keep it short and to the point. 1.16. What is the ratio of the Value added (% of GDP) in 1962 in Indonesia to that in Iran?
Give a very brief answer. 0.85. What is the ratio of the Value added (% of GDP) in 1963 in Indonesia to that in Iran?
Provide a succinct answer. 0.68. What is the ratio of the Value added (% of GDP) in 1960 in Indonesia to that in Kenya?
Ensure brevity in your answer.  0.98. What is the ratio of the Value added (% of GDP) in 1961 in Indonesia to that in Kenya?
Offer a terse response. 1.1. What is the ratio of the Value added (% of GDP) in 1962 in Indonesia to that in Kenya?
Provide a succinct answer. 0.95. What is the ratio of the Value added (% of GDP) of 1963 in Indonesia to that in Kenya?
Provide a succinct answer. 0.79. What is the ratio of the Value added (% of GDP) in 1960 in Iran to that in Kenya?
Give a very brief answer. 0.96. What is the ratio of the Value added (% of GDP) of 1961 in Iran to that in Kenya?
Your answer should be very brief. 0.95. What is the ratio of the Value added (% of GDP) of 1962 in Iran to that in Kenya?
Offer a terse response. 1.13. What is the ratio of the Value added (% of GDP) of 1963 in Iran to that in Kenya?
Your response must be concise. 1.17. What is the difference between the highest and the second highest Value added (% of GDP) in 1960?
Provide a succinct answer. 1.17. What is the difference between the highest and the second highest Value added (% of GDP) in 1961?
Ensure brevity in your answer.  1.96. What is the difference between the highest and the second highest Value added (% of GDP) in 1962?
Provide a short and direct response. 2.42. What is the difference between the highest and the second highest Value added (% of GDP) in 1963?
Offer a very short reply. 0.31. What is the difference between the highest and the lowest Value added (% of GDP) of 1960?
Keep it short and to the point. 4.65. What is the difference between the highest and the lowest Value added (% of GDP) in 1961?
Offer a very short reply. 4.92. What is the difference between the highest and the lowest Value added (% of GDP) of 1962?
Your answer should be compact. 6.01. What is the difference between the highest and the lowest Value added (% of GDP) of 1963?
Provide a short and direct response. 7.4. 